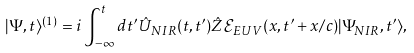Convert formula to latex. <formula><loc_0><loc_0><loc_500><loc_500>| \Psi , t \rangle ^ { ( 1 ) } = i \int _ { - \infty } ^ { t } d t ^ { \prime } \hat { U } _ { N I R } ( t , t ^ { \prime } ) \hat { Z } \mathcal { E } _ { E U V } ( x , t ^ { \prime } + x / c ) | \Psi _ { N I R } , t ^ { \prime } \rangle ,</formula> 